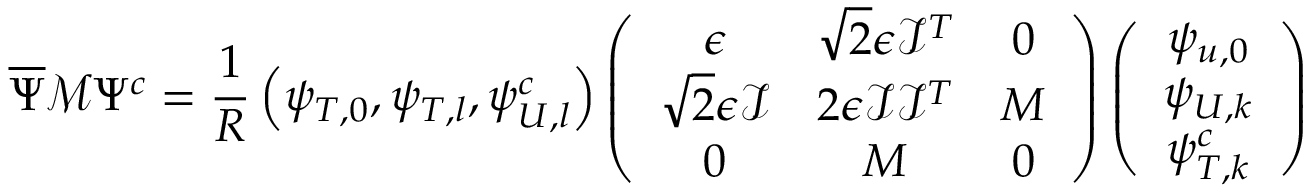<formula> <loc_0><loc_0><loc_500><loc_500>\overline { \Psi } \mathcal { M } \Psi ^ { c } = \frac { 1 } { R } \left ( \psi _ { T , 0 } , \psi _ { T , l } , \psi _ { U , l } ^ { c } \right ) \left ( \begin{array} { c c c } { \epsilon } & { { \sqrt { 2 } \epsilon \mathcal { I } ^ { T } } } & { 0 } \\ { { \sqrt { 2 } \epsilon \mathcal { I } } } & { { 2 \epsilon \mathcal { I } \mathcal { I } ^ { T } } } & { M } \\ { 0 } & { M } & { 0 } \end{array} \right ) \left ( \begin{array} { c } { { \psi _ { u , 0 } } } \\ { { \psi _ { U , k } } } \\ { { \psi _ { T , k } ^ { c } } } \end{array} \right )</formula> 